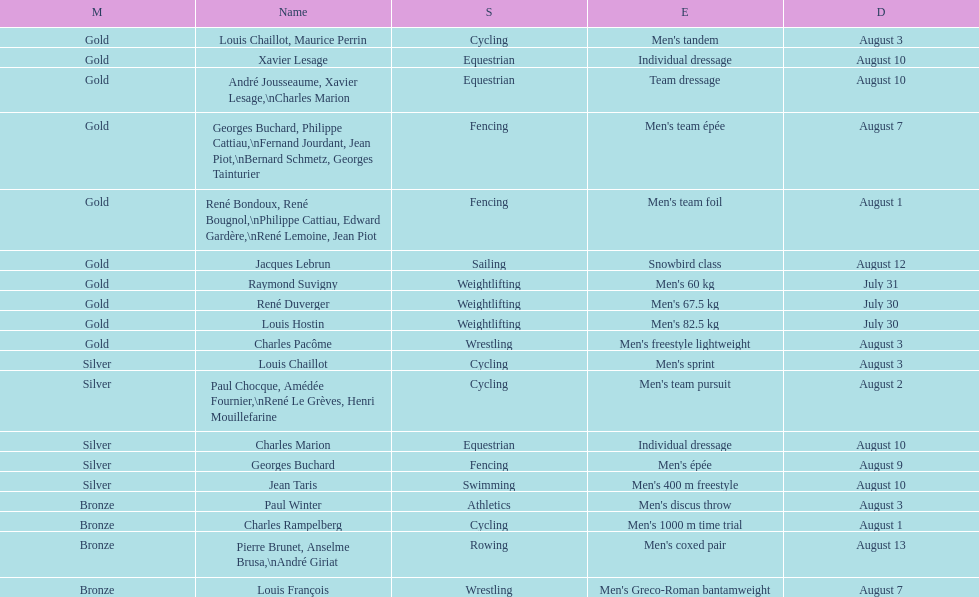How many medals were obtained after august 3? 9. 